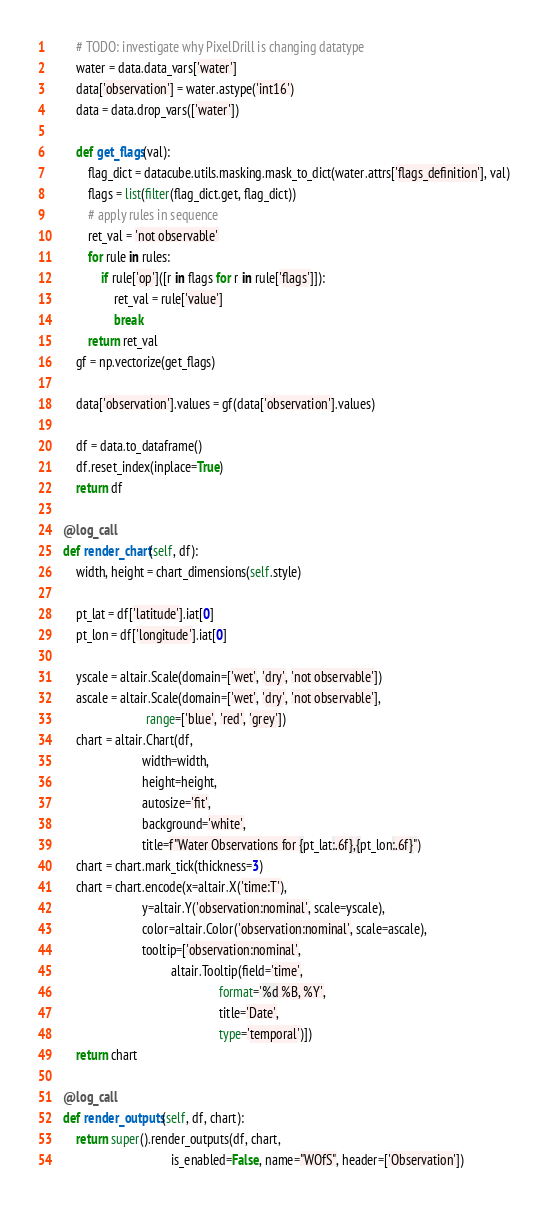Convert code to text. <code><loc_0><loc_0><loc_500><loc_500><_Python_>        # TODO: investigate why PixelDrill is changing datatype
        water = data.data_vars['water']
        data['observation'] = water.astype('int16')
        data = data.drop_vars(['water'])

        def get_flags(val):
            flag_dict = datacube.utils.masking.mask_to_dict(water.attrs['flags_definition'], val)
            flags = list(filter(flag_dict.get, flag_dict))
            # apply rules in sequence
            ret_val = 'not observable'
            for rule in rules:
                if rule['op']([r in flags for r in rule['flags']]):
                    ret_val = rule['value']
                    break
            return ret_val
        gf = np.vectorize(get_flags)

        data['observation'].values = gf(data['observation'].values)

        df = data.to_dataframe()
        df.reset_index(inplace=True)
        return df

    @log_call
    def render_chart(self, df):
        width, height = chart_dimensions(self.style)

        pt_lat = df['latitude'].iat[0]
        pt_lon = df['longitude'].iat[0]

        yscale = altair.Scale(domain=['wet', 'dry', 'not observable'])
        ascale = altair.Scale(domain=['wet', 'dry', 'not observable'],
                              range=['blue', 'red', 'grey'])
        chart = altair.Chart(df,
                             width=width,
                             height=height,
                             autosize='fit',
                             background='white',
                             title=f"Water Observations for {pt_lat:.6f},{pt_lon:.6f}")
        chart = chart.mark_tick(thickness=3)
        chart = chart.encode(x=altair.X('time:T'),
                             y=altair.Y('observation:nominal', scale=yscale),
                             color=altair.Color('observation:nominal', scale=ascale),
                             tooltip=['observation:nominal',
                                      altair.Tooltip(field='time',
                                                     format='%d %B, %Y',
                                                     title='Date',
                                                     type='temporal')])
        return chart

    @log_call
    def render_outputs(self, df, chart):
        return super().render_outputs(df, chart,
                                      is_enabled=False, name="WOfS", header=['Observation'])
</code> 